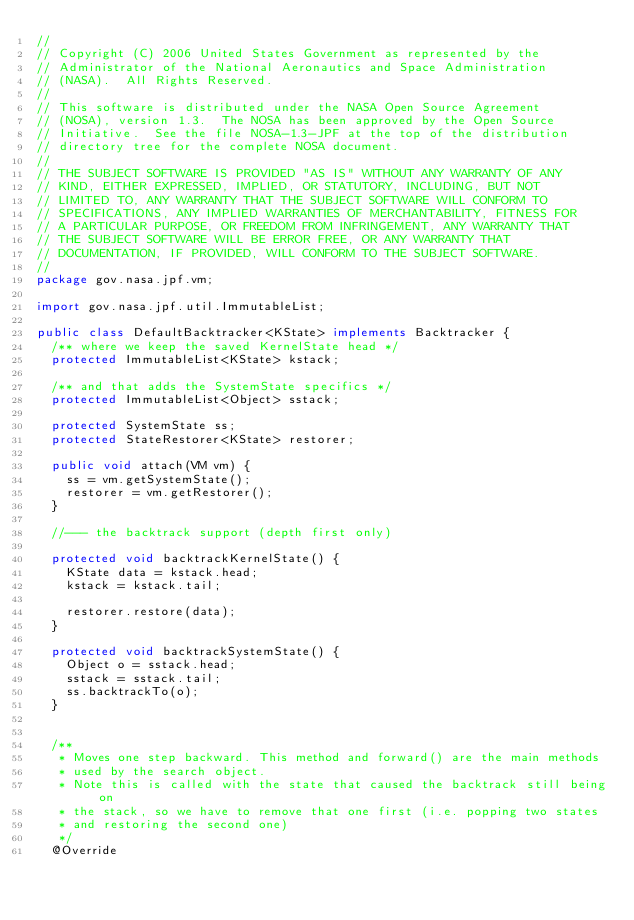<code> <loc_0><loc_0><loc_500><loc_500><_Java_>//
// Copyright (C) 2006 United States Government as represented by the
// Administrator of the National Aeronautics and Space Administration
// (NASA).  All Rights Reserved.
// 
// This software is distributed under the NASA Open Source Agreement
// (NOSA), version 1.3.  The NOSA has been approved by the Open Source
// Initiative.  See the file NOSA-1.3-JPF at the top of the distribution
// directory tree for the complete NOSA document.
// 
// THE SUBJECT SOFTWARE IS PROVIDED "AS IS" WITHOUT ANY WARRANTY OF ANY
// KIND, EITHER EXPRESSED, IMPLIED, OR STATUTORY, INCLUDING, BUT NOT
// LIMITED TO, ANY WARRANTY THAT THE SUBJECT SOFTWARE WILL CONFORM TO
// SPECIFICATIONS, ANY IMPLIED WARRANTIES OF MERCHANTABILITY, FITNESS FOR
// A PARTICULAR PURPOSE, OR FREEDOM FROM INFRINGEMENT, ANY WARRANTY THAT
// THE SUBJECT SOFTWARE WILL BE ERROR FREE, OR ANY WARRANTY THAT
// DOCUMENTATION, IF PROVIDED, WILL CONFORM TO THE SUBJECT SOFTWARE.
//
package gov.nasa.jpf.vm;

import gov.nasa.jpf.util.ImmutableList;

public class DefaultBacktracker<KState> implements Backtracker {
  /** where we keep the saved KernelState head */ 
  protected ImmutableList<KState> kstack;
   
  /** and that adds the SystemState specifics */
  protected ImmutableList<Object> sstack;
  
  protected SystemState ss;
  protected StateRestorer<KState> restorer;
  
  public void attach(VM vm) {
    ss = vm.getSystemState();
    restorer = vm.getRestorer();
  }

  //--- the backtrack support (depth first only)
  
  protected void backtrackKernelState() {
    KState data = kstack.head;
    kstack = kstack.tail;
    
    restorer.restore(data);
  }

  protected void backtrackSystemState() {
    Object o = sstack.head;
    sstack = sstack.tail;
    ss.backtrackTo(o);
  }

  
  /**
   * Moves one step backward. This method and forward() are the main methods
   * used by the search object.
   * Note this is called with the state that caused the backtrack still being on
   * the stack, so we have to remove that one first (i.e. popping two states
   * and restoring the second one)
   */
  @Override</code> 